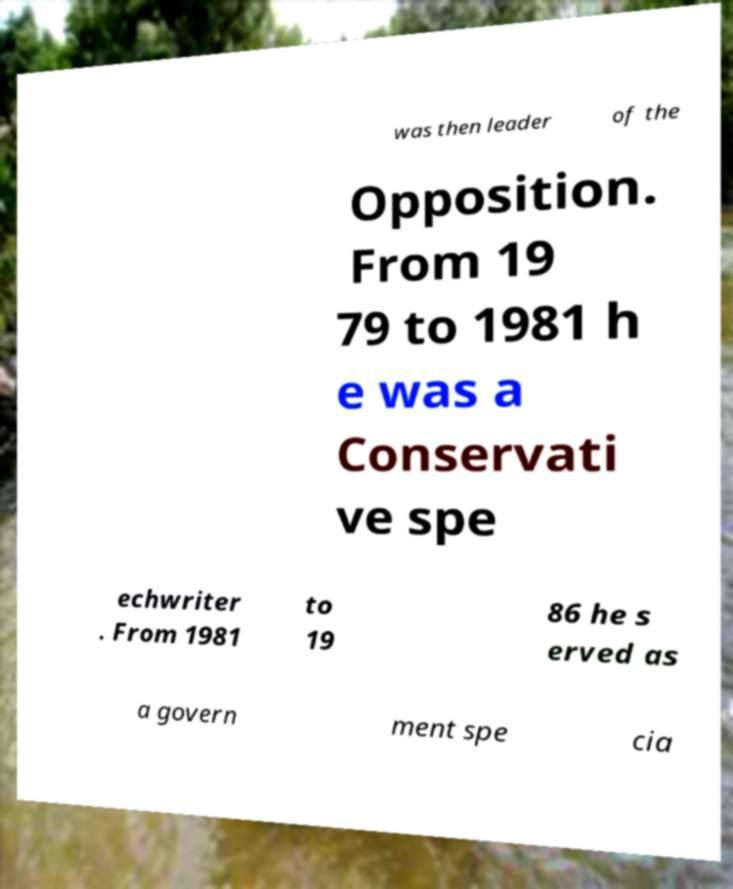Could you assist in decoding the text presented in this image and type it out clearly? was then leader of the Opposition. From 19 79 to 1981 h e was a Conservati ve spe echwriter . From 1981 to 19 86 he s erved as a govern ment spe cia 